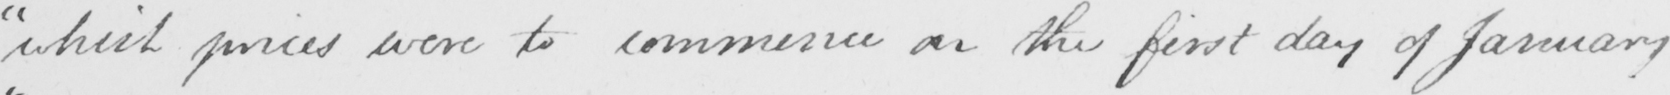Transcribe the text shown in this historical manuscript line. " which prices were to commence on the first day of January 